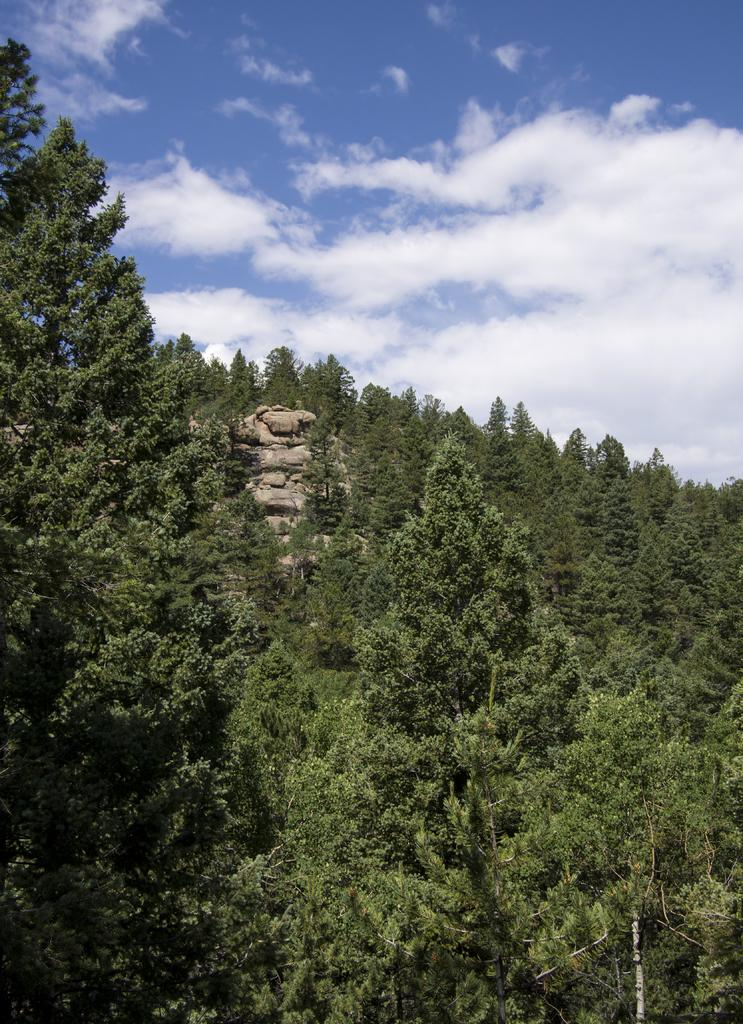What type of view is shown in the image? The image is an aerial view. What natural elements can be seen in the image? There are trees and rocks visible in the image. What is visible in the sky at the top of the image? Clouds are present in the sky at the top of the image. What statement does the tramp make while walking through the trees in the image? There is no tramp or statement present in the image; it is an aerial view of trees and rocks with clouds in the sky. 